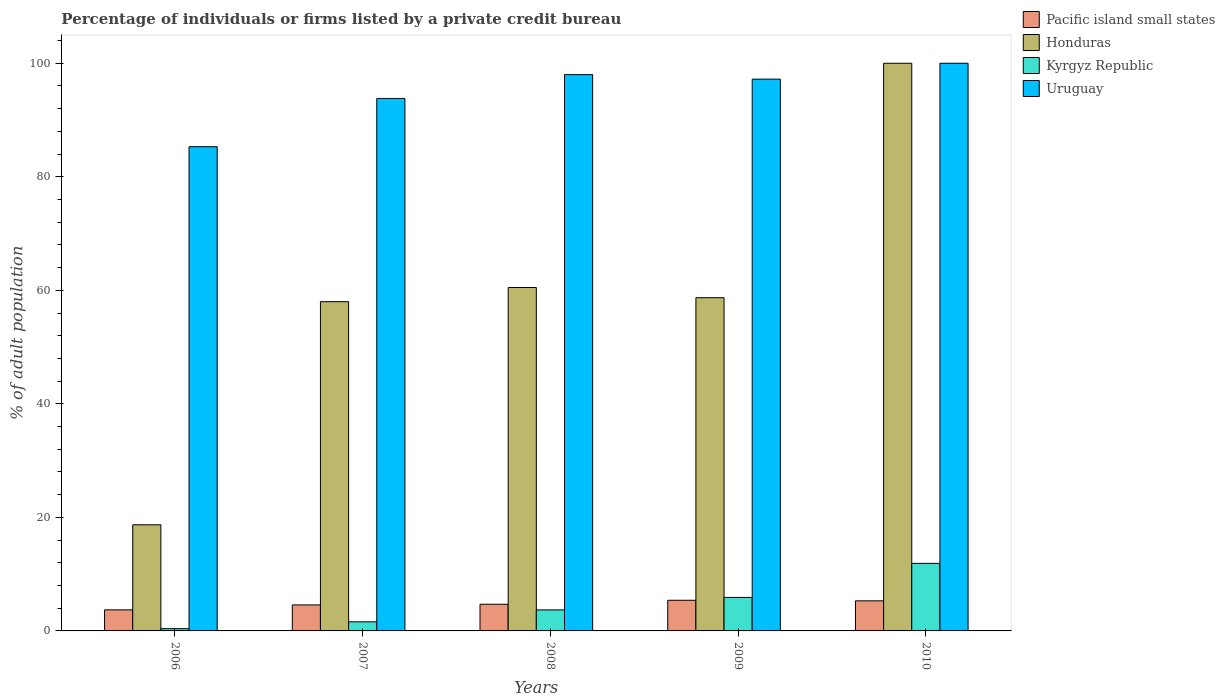How many bars are there on the 3rd tick from the right?
Ensure brevity in your answer.  4. What is the label of the 1st group of bars from the left?
Your response must be concise. 2006. In how many cases, is the number of bars for a given year not equal to the number of legend labels?
Provide a succinct answer. 0. Across all years, what is the maximum percentage of population listed by a private credit bureau in Kyrgyz Republic?
Give a very brief answer. 11.9. Across all years, what is the minimum percentage of population listed by a private credit bureau in Uruguay?
Give a very brief answer. 85.3. In which year was the percentage of population listed by a private credit bureau in Uruguay maximum?
Keep it short and to the point. 2010. In which year was the percentage of population listed by a private credit bureau in Uruguay minimum?
Offer a terse response. 2006. What is the difference between the percentage of population listed by a private credit bureau in Pacific island small states in 2007 and that in 2010?
Provide a succinct answer. -0.72. What is the difference between the percentage of population listed by a private credit bureau in Pacific island small states in 2010 and the percentage of population listed by a private credit bureau in Kyrgyz Republic in 2009?
Provide a succinct answer. -0.6. In the year 2009, what is the difference between the percentage of population listed by a private credit bureau in Kyrgyz Republic and percentage of population listed by a private credit bureau in Uruguay?
Your response must be concise. -91.3. What is the ratio of the percentage of population listed by a private credit bureau in Kyrgyz Republic in 2008 to that in 2009?
Your answer should be very brief. 0.63. Is the percentage of population listed by a private credit bureau in Kyrgyz Republic in 2006 less than that in 2008?
Make the answer very short. Yes. What is the difference between the highest and the lowest percentage of population listed by a private credit bureau in Honduras?
Offer a terse response. 81.3. What does the 3rd bar from the left in 2008 represents?
Provide a succinct answer. Kyrgyz Republic. What does the 4th bar from the right in 2007 represents?
Your answer should be compact. Pacific island small states. How many bars are there?
Your response must be concise. 20. How many years are there in the graph?
Your answer should be compact. 5. What is the difference between two consecutive major ticks on the Y-axis?
Make the answer very short. 20. Are the values on the major ticks of Y-axis written in scientific E-notation?
Offer a very short reply. No. Does the graph contain any zero values?
Offer a very short reply. No. Where does the legend appear in the graph?
Make the answer very short. Top right. How are the legend labels stacked?
Your response must be concise. Vertical. What is the title of the graph?
Ensure brevity in your answer.  Percentage of individuals or firms listed by a private credit bureau. What is the label or title of the Y-axis?
Ensure brevity in your answer.  % of adult population. What is the % of adult population in Pacific island small states in 2006?
Your response must be concise. 3.71. What is the % of adult population of Honduras in 2006?
Provide a succinct answer. 18.7. What is the % of adult population of Uruguay in 2006?
Provide a succinct answer. 85.3. What is the % of adult population in Pacific island small states in 2007?
Offer a terse response. 4.58. What is the % of adult population in Honduras in 2007?
Provide a succinct answer. 58. What is the % of adult population of Uruguay in 2007?
Offer a very short reply. 93.8. What is the % of adult population in Honduras in 2008?
Make the answer very short. 60.5. What is the % of adult population in Kyrgyz Republic in 2008?
Make the answer very short. 3.7. What is the % of adult population in Pacific island small states in 2009?
Ensure brevity in your answer.  5.4. What is the % of adult population of Honduras in 2009?
Ensure brevity in your answer.  58.7. What is the % of adult population in Uruguay in 2009?
Your response must be concise. 97.2. What is the % of adult population in Pacific island small states in 2010?
Offer a terse response. 5.3. What is the % of adult population in Kyrgyz Republic in 2010?
Make the answer very short. 11.9. What is the % of adult population of Uruguay in 2010?
Your answer should be very brief. 100. Across all years, what is the maximum % of adult population in Pacific island small states?
Give a very brief answer. 5.4. Across all years, what is the maximum % of adult population in Honduras?
Your answer should be compact. 100. Across all years, what is the maximum % of adult population of Uruguay?
Give a very brief answer. 100. Across all years, what is the minimum % of adult population of Pacific island small states?
Make the answer very short. 3.71. Across all years, what is the minimum % of adult population in Honduras?
Make the answer very short. 18.7. Across all years, what is the minimum % of adult population in Kyrgyz Republic?
Make the answer very short. 0.4. Across all years, what is the minimum % of adult population in Uruguay?
Ensure brevity in your answer.  85.3. What is the total % of adult population in Pacific island small states in the graph?
Your answer should be very brief. 23.69. What is the total % of adult population in Honduras in the graph?
Offer a very short reply. 295.9. What is the total % of adult population of Kyrgyz Republic in the graph?
Your response must be concise. 23.5. What is the total % of adult population in Uruguay in the graph?
Your answer should be very brief. 474.3. What is the difference between the % of adult population in Pacific island small states in 2006 and that in 2007?
Offer a very short reply. -0.87. What is the difference between the % of adult population in Honduras in 2006 and that in 2007?
Your response must be concise. -39.3. What is the difference between the % of adult population of Kyrgyz Republic in 2006 and that in 2007?
Offer a terse response. -1.2. What is the difference between the % of adult population of Uruguay in 2006 and that in 2007?
Your response must be concise. -8.5. What is the difference between the % of adult population of Pacific island small states in 2006 and that in 2008?
Provide a succinct answer. -0.99. What is the difference between the % of adult population in Honduras in 2006 and that in 2008?
Ensure brevity in your answer.  -41.8. What is the difference between the % of adult population in Uruguay in 2006 and that in 2008?
Provide a short and direct response. -12.7. What is the difference between the % of adult population in Pacific island small states in 2006 and that in 2009?
Provide a short and direct response. -1.69. What is the difference between the % of adult population of Kyrgyz Republic in 2006 and that in 2009?
Your response must be concise. -5.5. What is the difference between the % of adult population of Uruguay in 2006 and that in 2009?
Your answer should be very brief. -11.9. What is the difference between the % of adult population in Pacific island small states in 2006 and that in 2010?
Offer a terse response. -1.59. What is the difference between the % of adult population in Honduras in 2006 and that in 2010?
Make the answer very short. -81.3. What is the difference between the % of adult population of Uruguay in 2006 and that in 2010?
Provide a succinct answer. -14.7. What is the difference between the % of adult population of Pacific island small states in 2007 and that in 2008?
Ensure brevity in your answer.  -0.12. What is the difference between the % of adult population in Honduras in 2007 and that in 2008?
Offer a terse response. -2.5. What is the difference between the % of adult population in Pacific island small states in 2007 and that in 2009?
Your answer should be very brief. -0.82. What is the difference between the % of adult population of Pacific island small states in 2007 and that in 2010?
Keep it short and to the point. -0.72. What is the difference between the % of adult population in Honduras in 2007 and that in 2010?
Provide a succinct answer. -42. What is the difference between the % of adult population in Kyrgyz Republic in 2007 and that in 2010?
Provide a succinct answer. -10.3. What is the difference between the % of adult population of Uruguay in 2007 and that in 2010?
Make the answer very short. -6.2. What is the difference between the % of adult population in Honduras in 2008 and that in 2009?
Provide a succinct answer. 1.8. What is the difference between the % of adult population of Uruguay in 2008 and that in 2009?
Provide a short and direct response. 0.8. What is the difference between the % of adult population of Honduras in 2008 and that in 2010?
Provide a short and direct response. -39.5. What is the difference between the % of adult population in Pacific island small states in 2009 and that in 2010?
Your response must be concise. 0.1. What is the difference between the % of adult population in Honduras in 2009 and that in 2010?
Your answer should be compact. -41.3. What is the difference between the % of adult population of Kyrgyz Republic in 2009 and that in 2010?
Keep it short and to the point. -6. What is the difference between the % of adult population in Pacific island small states in 2006 and the % of adult population in Honduras in 2007?
Your answer should be compact. -54.29. What is the difference between the % of adult population of Pacific island small states in 2006 and the % of adult population of Kyrgyz Republic in 2007?
Provide a short and direct response. 2.11. What is the difference between the % of adult population in Pacific island small states in 2006 and the % of adult population in Uruguay in 2007?
Your answer should be compact. -90.09. What is the difference between the % of adult population of Honduras in 2006 and the % of adult population of Uruguay in 2007?
Your response must be concise. -75.1. What is the difference between the % of adult population of Kyrgyz Republic in 2006 and the % of adult population of Uruguay in 2007?
Offer a terse response. -93.4. What is the difference between the % of adult population in Pacific island small states in 2006 and the % of adult population in Honduras in 2008?
Keep it short and to the point. -56.79. What is the difference between the % of adult population in Pacific island small states in 2006 and the % of adult population in Kyrgyz Republic in 2008?
Your answer should be very brief. 0.01. What is the difference between the % of adult population in Pacific island small states in 2006 and the % of adult population in Uruguay in 2008?
Provide a succinct answer. -94.29. What is the difference between the % of adult population of Honduras in 2006 and the % of adult population of Uruguay in 2008?
Provide a short and direct response. -79.3. What is the difference between the % of adult population of Kyrgyz Republic in 2006 and the % of adult population of Uruguay in 2008?
Provide a short and direct response. -97.6. What is the difference between the % of adult population of Pacific island small states in 2006 and the % of adult population of Honduras in 2009?
Provide a short and direct response. -54.99. What is the difference between the % of adult population of Pacific island small states in 2006 and the % of adult population of Kyrgyz Republic in 2009?
Your answer should be very brief. -2.19. What is the difference between the % of adult population of Pacific island small states in 2006 and the % of adult population of Uruguay in 2009?
Offer a very short reply. -93.49. What is the difference between the % of adult population in Honduras in 2006 and the % of adult population in Kyrgyz Republic in 2009?
Your answer should be very brief. 12.8. What is the difference between the % of adult population in Honduras in 2006 and the % of adult population in Uruguay in 2009?
Keep it short and to the point. -78.5. What is the difference between the % of adult population of Kyrgyz Republic in 2006 and the % of adult population of Uruguay in 2009?
Provide a succinct answer. -96.8. What is the difference between the % of adult population of Pacific island small states in 2006 and the % of adult population of Honduras in 2010?
Provide a short and direct response. -96.29. What is the difference between the % of adult population in Pacific island small states in 2006 and the % of adult population in Kyrgyz Republic in 2010?
Keep it short and to the point. -8.19. What is the difference between the % of adult population in Pacific island small states in 2006 and the % of adult population in Uruguay in 2010?
Offer a very short reply. -96.29. What is the difference between the % of adult population in Honduras in 2006 and the % of adult population in Kyrgyz Republic in 2010?
Make the answer very short. 6.8. What is the difference between the % of adult population in Honduras in 2006 and the % of adult population in Uruguay in 2010?
Offer a terse response. -81.3. What is the difference between the % of adult population of Kyrgyz Republic in 2006 and the % of adult population of Uruguay in 2010?
Make the answer very short. -99.6. What is the difference between the % of adult population of Pacific island small states in 2007 and the % of adult population of Honduras in 2008?
Provide a succinct answer. -55.92. What is the difference between the % of adult population in Pacific island small states in 2007 and the % of adult population in Kyrgyz Republic in 2008?
Offer a terse response. 0.88. What is the difference between the % of adult population in Pacific island small states in 2007 and the % of adult population in Uruguay in 2008?
Offer a terse response. -93.42. What is the difference between the % of adult population of Honduras in 2007 and the % of adult population of Kyrgyz Republic in 2008?
Give a very brief answer. 54.3. What is the difference between the % of adult population of Honduras in 2007 and the % of adult population of Uruguay in 2008?
Keep it short and to the point. -40. What is the difference between the % of adult population in Kyrgyz Republic in 2007 and the % of adult population in Uruguay in 2008?
Keep it short and to the point. -96.4. What is the difference between the % of adult population in Pacific island small states in 2007 and the % of adult population in Honduras in 2009?
Keep it short and to the point. -54.12. What is the difference between the % of adult population in Pacific island small states in 2007 and the % of adult population in Kyrgyz Republic in 2009?
Your answer should be compact. -1.32. What is the difference between the % of adult population in Pacific island small states in 2007 and the % of adult population in Uruguay in 2009?
Offer a very short reply. -92.62. What is the difference between the % of adult population of Honduras in 2007 and the % of adult population of Kyrgyz Republic in 2009?
Give a very brief answer. 52.1. What is the difference between the % of adult population of Honduras in 2007 and the % of adult population of Uruguay in 2009?
Keep it short and to the point. -39.2. What is the difference between the % of adult population in Kyrgyz Republic in 2007 and the % of adult population in Uruguay in 2009?
Your response must be concise. -95.6. What is the difference between the % of adult population in Pacific island small states in 2007 and the % of adult population in Honduras in 2010?
Give a very brief answer. -95.42. What is the difference between the % of adult population of Pacific island small states in 2007 and the % of adult population of Kyrgyz Republic in 2010?
Offer a terse response. -7.32. What is the difference between the % of adult population of Pacific island small states in 2007 and the % of adult population of Uruguay in 2010?
Make the answer very short. -95.42. What is the difference between the % of adult population in Honduras in 2007 and the % of adult population in Kyrgyz Republic in 2010?
Provide a succinct answer. 46.1. What is the difference between the % of adult population in Honduras in 2007 and the % of adult population in Uruguay in 2010?
Keep it short and to the point. -42. What is the difference between the % of adult population in Kyrgyz Republic in 2007 and the % of adult population in Uruguay in 2010?
Provide a short and direct response. -98.4. What is the difference between the % of adult population in Pacific island small states in 2008 and the % of adult population in Honduras in 2009?
Ensure brevity in your answer.  -54. What is the difference between the % of adult population of Pacific island small states in 2008 and the % of adult population of Kyrgyz Republic in 2009?
Your answer should be compact. -1.2. What is the difference between the % of adult population of Pacific island small states in 2008 and the % of adult population of Uruguay in 2009?
Provide a short and direct response. -92.5. What is the difference between the % of adult population in Honduras in 2008 and the % of adult population in Kyrgyz Republic in 2009?
Provide a short and direct response. 54.6. What is the difference between the % of adult population of Honduras in 2008 and the % of adult population of Uruguay in 2009?
Provide a succinct answer. -36.7. What is the difference between the % of adult population of Kyrgyz Republic in 2008 and the % of adult population of Uruguay in 2009?
Your answer should be compact. -93.5. What is the difference between the % of adult population in Pacific island small states in 2008 and the % of adult population in Honduras in 2010?
Offer a terse response. -95.3. What is the difference between the % of adult population in Pacific island small states in 2008 and the % of adult population in Kyrgyz Republic in 2010?
Offer a terse response. -7.2. What is the difference between the % of adult population in Pacific island small states in 2008 and the % of adult population in Uruguay in 2010?
Offer a very short reply. -95.3. What is the difference between the % of adult population in Honduras in 2008 and the % of adult population in Kyrgyz Republic in 2010?
Your answer should be compact. 48.6. What is the difference between the % of adult population in Honduras in 2008 and the % of adult population in Uruguay in 2010?
Offer a terse response. -39.5. What is the difference between the % of adult population in Kyrgyz Republic in 2008 and the % of adult population in Uruguay in 2010?
Provide a succinct answer. -96.3. What is the difference between the % of adult population of Pacific island small states in 2009 and the % of adult population of Honduras in 2010?
Give a very brief answer. -94.6. What is the difference between the % of adult population in Pacific island small states in 2009 and the % of adult population in Kyrgyz Republic in 2010?
Your answer should be very brief. -6.5. What is the difference between the % of adult population of Pacific island small states in 2009 and the % of adult population of Uruguay in 2010?
Your answer should be compact. -94.6. What is the difference between the % of adult population in Honduras in 2009 and the % of adult population in Kyrgyz Republic in 2010?
Give a very brief answer. 46.8. What is the difference between the % of adult population in Honduras in 2009 and the % of adult population in Uruguay in 2010?
Provide a succinct answer. -41.3. What is the difference between the % of adult population of Kyrgyz Republic in 2009 and the % of adult population of Uruguay in 2010?
Make the answer very short. -94.1. What is the average % of adult population in Pacific island small states per year?
Provide a short and direct response. 4.74. What is the average % of adult population of Honduras per year?
Your answer should be compact. 59.18. What is the average % of adult population in Kyrgyz Republic per year?
Provide a succinct answer. 4.7. What is the average % of adult population of Uruguay per year?
Your response must be concise. 94.86. In the year 2006, what is the difference between the % of adult population in Pacific island small states and % of adult population in Honduras?
Make the answer very short. -14.99. In the year 2006, what is the difference between the % of adult population of Pacific island small states and % of adult population of Kyrgyz Republic?
Give a very brief answer. 3.31. In the year 2006, what is the difference between the % of adult population in Pacific island small states and % of adult population in Uruguay?
Offer a terse response. -81.59. In the year 2006, what is the difference between the % of adult population in Honduras and % of adult population in Kyrgyz Republic?
Ensure brevity in your answer.  18.3. In the year 2006, what is the difference between the % of adult population in Honduras and % of adult population in Uruguay?
Your answer should be very brief. -66.6. In the year 2006, what is the difference between the % of adult population in Kyrgyz Republic and % of adult population in Uruguay?
Give a very brief answer. -84.9. In the year 2007, what is the difference between the % of adult population of Pacific island small states and % of adult population of Honduras?
Offer a terse response. -53.42. In the year 2007, what is the difference between the % of adult population in Pacific island small states and % of adult population in Kyrgyz Republic?
Offer a terse response. 2.98. In the year 2007, what is the difference between the % of adult population in Pacific island small states and % of adult population in Uruguay?
Offer a terse response. -89.22. In the year 2007, what is the difference between the % of adult population of Honduras and % of adult population of Kyrgyz Republic?
Provide a short and direct response. 56.4. In the year 2007, what is the difference between the % of adult population of Honduras and % of adult population of Uruguay?
Offer a very short reply. -35.8. In the year 2007, what is the difference between the % of adult population in Kyrgyz Republic and % of adult population in Uruguay?
Keep it short and to the point. -92.2. In the year 2008, what is the difference between the % of adult population in Pacific island small states and % of adult population in Honduras?
Provide a short and direct response. -55.8. In the year 2008, what is the difference between the % of adult population in Pacific island small states and % of adult population in Uruguay?
Provide a succinct answer. -93.3. In the year 2008, what is the difference between the % of adult population in Honduras and % of adult population in Kyrgyz Republic?
Keep it short and to the point. 56.8. In the year 2008, what is the difference between the % of adult population of Honduras and % of adult population of Uruguay?
Give a very brief answer. -37.5. In the year 2008, what is the difference between the % of adult population in Kyrgyz Republic and % of adult population in Uruguay?
Ensure brevity in your answer.  -94.3. In the year 2009, what is the difference between the % of adult population of Pacific island small states and % of adult population of Honduras?
Ensure brevity in your answer.  -53.3. In the year 2009, what is the difference between the % of adult population of Pacific island small states and % of adult population of Uruguay?
Your answer should be compact. -91.8. In the year 2009, what is the difference between the % of adult population in Honduras and % of adult population in Kyrgyz Republic?
Your answer should be compact. 52.8. In the year 2009, what is the difference between the % of adult population of Honduras and % of adult population of Uruguay?
Your response must be concise. -38.5. In the year 2009, what is the difference between the % of adult population of Kyrgyz Republic and % of adult population of Uruguay?
Your response must be concise. -91.3. In the year 2010, what is the difference between the % of adult population of Pacific island small states and % of adult population of Honduras?
Your answer should be very brief. -94.7. In the year 2010, what is the difference between the % of adult population of Pacific island small states and % of adult population of Kyrgyz Republic?
Your response must be concise. -6.6. In the year 2010, what is the difference between the % of adult population in Pacific island small states and % of adult population in Uruguay?
Provide a short and direct response. -94.7. In the year 2010, what is the difference between the % of adult population of Honduras and % of adult population of Kyrgyz Republic?
Give a very brief answer. 88.1. In the year 2010, what is the difference between the % of adult population in Honduras and % of adult population in Uruguay?
Your answer should be compact. 0. In the year 2010, what is the difference between the % of adult population of Kyrgyz Republic and % of adult population of Uruguay?
Offer a terse response. -88.1. What is the ratio of the % of adult population of Pacific island small states in 2006 to that in 2007?
Your answer should be very brief. 0.81. What is the ratio of the % of adult population of Honduras in 2006 to that in 2007?
Provide a succinct answer. 0.32. What is the ratio of the % of adult population in Uruguay in 2006 to that in 2007?
Provide a short and direct response. 0.91. What is the ratio of the % of adult population in Pacific island small states in 2006 to that in 2008?
Your answer should be compact. 0.79. What is the ratio of the % of adult population in Honduras in 2006 to that in 2008?
Provide a short and direct response. 0.31. What is the ratio of the % of adult population in Kyrgyz Republic in 2006 to that in 2008?
Your answer should be very brief. 0.11. What is the ratio of the % of adult population in Uruguay in 2006 to that in 2008?
Give a very brief answer. 0.87. What is the ratio of the % of adult population in Pacific island small states in 2006 to that in 2009?
Offer a terse response. 0.69. What is the ratio of the % of adult population in Honduras in 2006 to that in 2009?
Offer a terse response. 0.32. What is the ratio of the % of adult population of Kyrgyz Republic in 2006 to that in 2009?
Ensure brevity in your answer.  0.07. What is the ratio of the % of adult population of Uruguay in 2006 to that in 2009?
Your response must be concise. 0.88. What is the ratio of the % of adult population of Pacific island small states in 2006 to that in 2010?
Provide a short and direct response. 0.7. What is the ratio of the % of adult population in Honduras in 2006 to that in 2010?
Give a very brief answer. 0.19. What is the ratio of the % of adult population of Kyrgyz Republic in 2006 to that in 2010?
Make the answer very short. 0.03. What is the ratio of the % of adult population of Uruguay in 2006 to that in 2010?
Ensure brevity in your answer.  0.85. What is the ratio of the % of adult population of Pacific island small states in 2007 to that in 2008?
Your response must be concise. 0.97. What is the ratio of the % of adult population in Honduras in 2007 to that in 2008?
Your answer should be compact. 0.96. What is the ratio of the % of adult population in Kyrgyz Republic in 2007 to that in 2008?
Offer a terse response. 0.43. What is the ratio of the % of adult population of Uruguay in 2007 to that in 2008?
Ensure brevity in your answer.  0.96. What is the ratio of the % of adult population of Pacific island small states in 2007 to that in 2009?
Offer a very short reply. 0.85. What is the ratio of the % of adult population of Kyrgyz Republic in 2007 to that in 2009?
Offer a very short reply. 0.27. What is the ratio of the % of adult population of Pacific island small states in 2007 to that in 2010?
Offer a very short reply. 0.86. What is the ratio of the % of adult population in Honduras in 2007 to that in 2010?
Keep it short and to the point. 0.58. What is the ratio of the % of adult population of Kyrgyz Republic in 2007 to that in 2010?
Provide a succinct answer. 0.13. What is the ratio of the % of adult population in Uruguay in 2007 to that in 2010?
Ensure brevity in your answer.  0.94. What is the ratio of the % of adult population in Pacific island small states in 2008 to that in 2009?
Your answer should be compact. 0.87. What is the ratio of the % of adult population in Honduras in 2008 to that in 2009?
Provide a short and direct response. 1.03. What is the ratio of the % of adult population of Kyrgyz Republic in 2008 to that in 2009?
Your answer should be compact. 0.63. What is the ratio of the % of adult population of Uruguay in 2008 to that in 2009?
Give a very brief answer. 1.01. What is the ratio of the % of adult population of Pacific island small states in 2008 to that in 2010?
Offer a very short reply. 0.89. What is the ratio of the % of adult population in Honduras in 2008 to that in 2010?
Your response must be concise. 0.6. What is the ratio of the % of adult population of Kyrgyz Republic in 2008 to that in 2010?
Provide a succinct answer. 0.31. What is the ratio of the % of adult population in Pacific island small states in 2009 to that in 2010?
Provide a short and direct response. 1.02. What is the ratio of the % of adult population in Honduras in 2009 to that in 2010?
Provide a succinct answer. 0.59. What is the ratio of the % of adult population in Kyrgyz Republic in 2009 to that in 2010?
Ensure brevity in your answer.  0.5. What is the difference between the highest and the second highest % of adult population of Honduras?
Keep it short and to the point. 39.5. What is the difference between the highest and the second highest % of adult population in Uruguay?
Offer a very short reply. 2. What is the difference between the highest and the lowest % of adult population in Pacific island small states?
Ensure brevity in your answer.  1.69. What is the difference between the highest and the lowest % of adult population in Honduras?
Give a very brief answer. 81.3. 